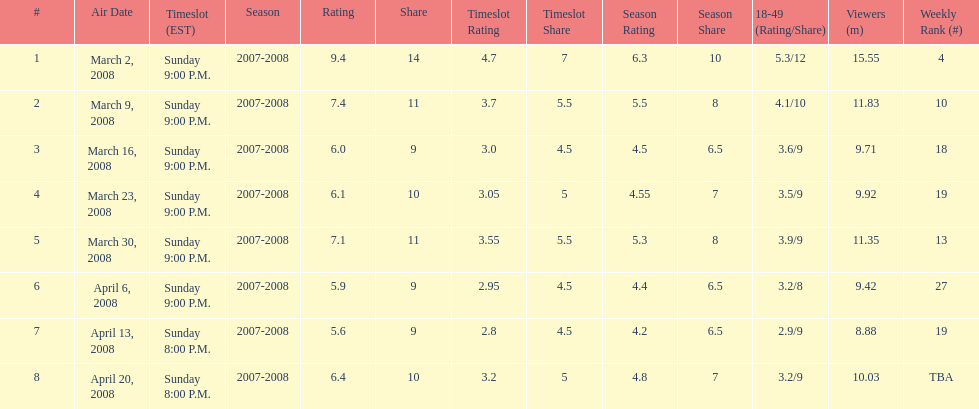What episode had the highest rating? March 2, 2008. 